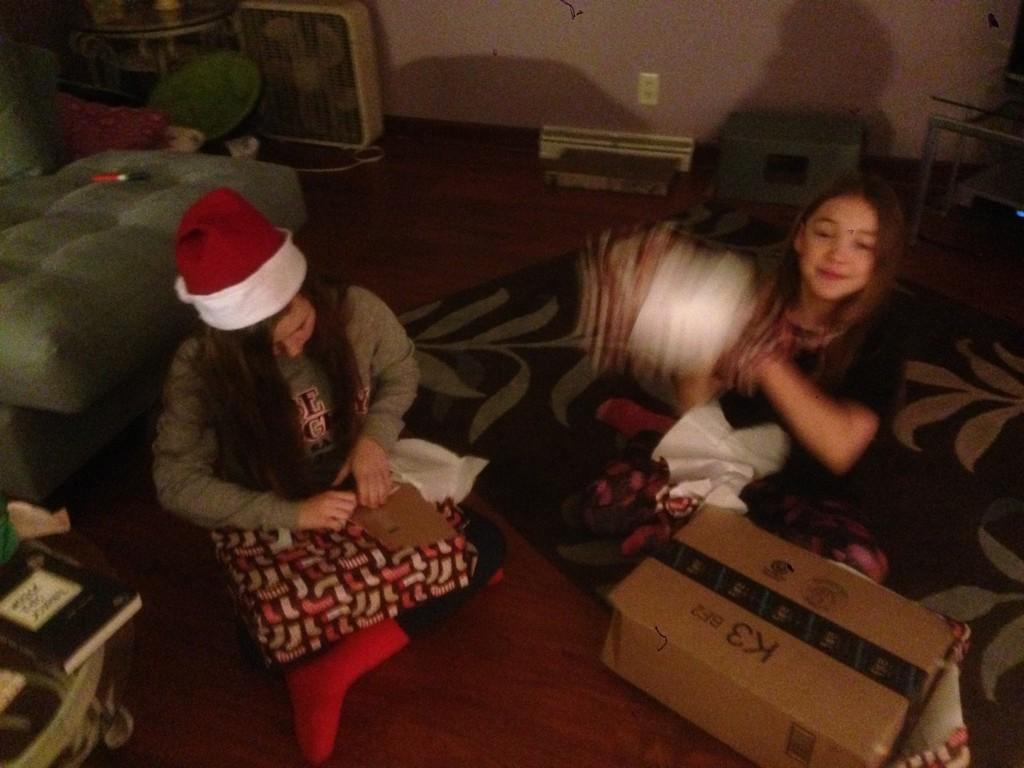Can you describe this image briefly? In this picture we can see two persons are sitting on the floor. This is sofa and there is a box. On the background there is a wall and this is book. 